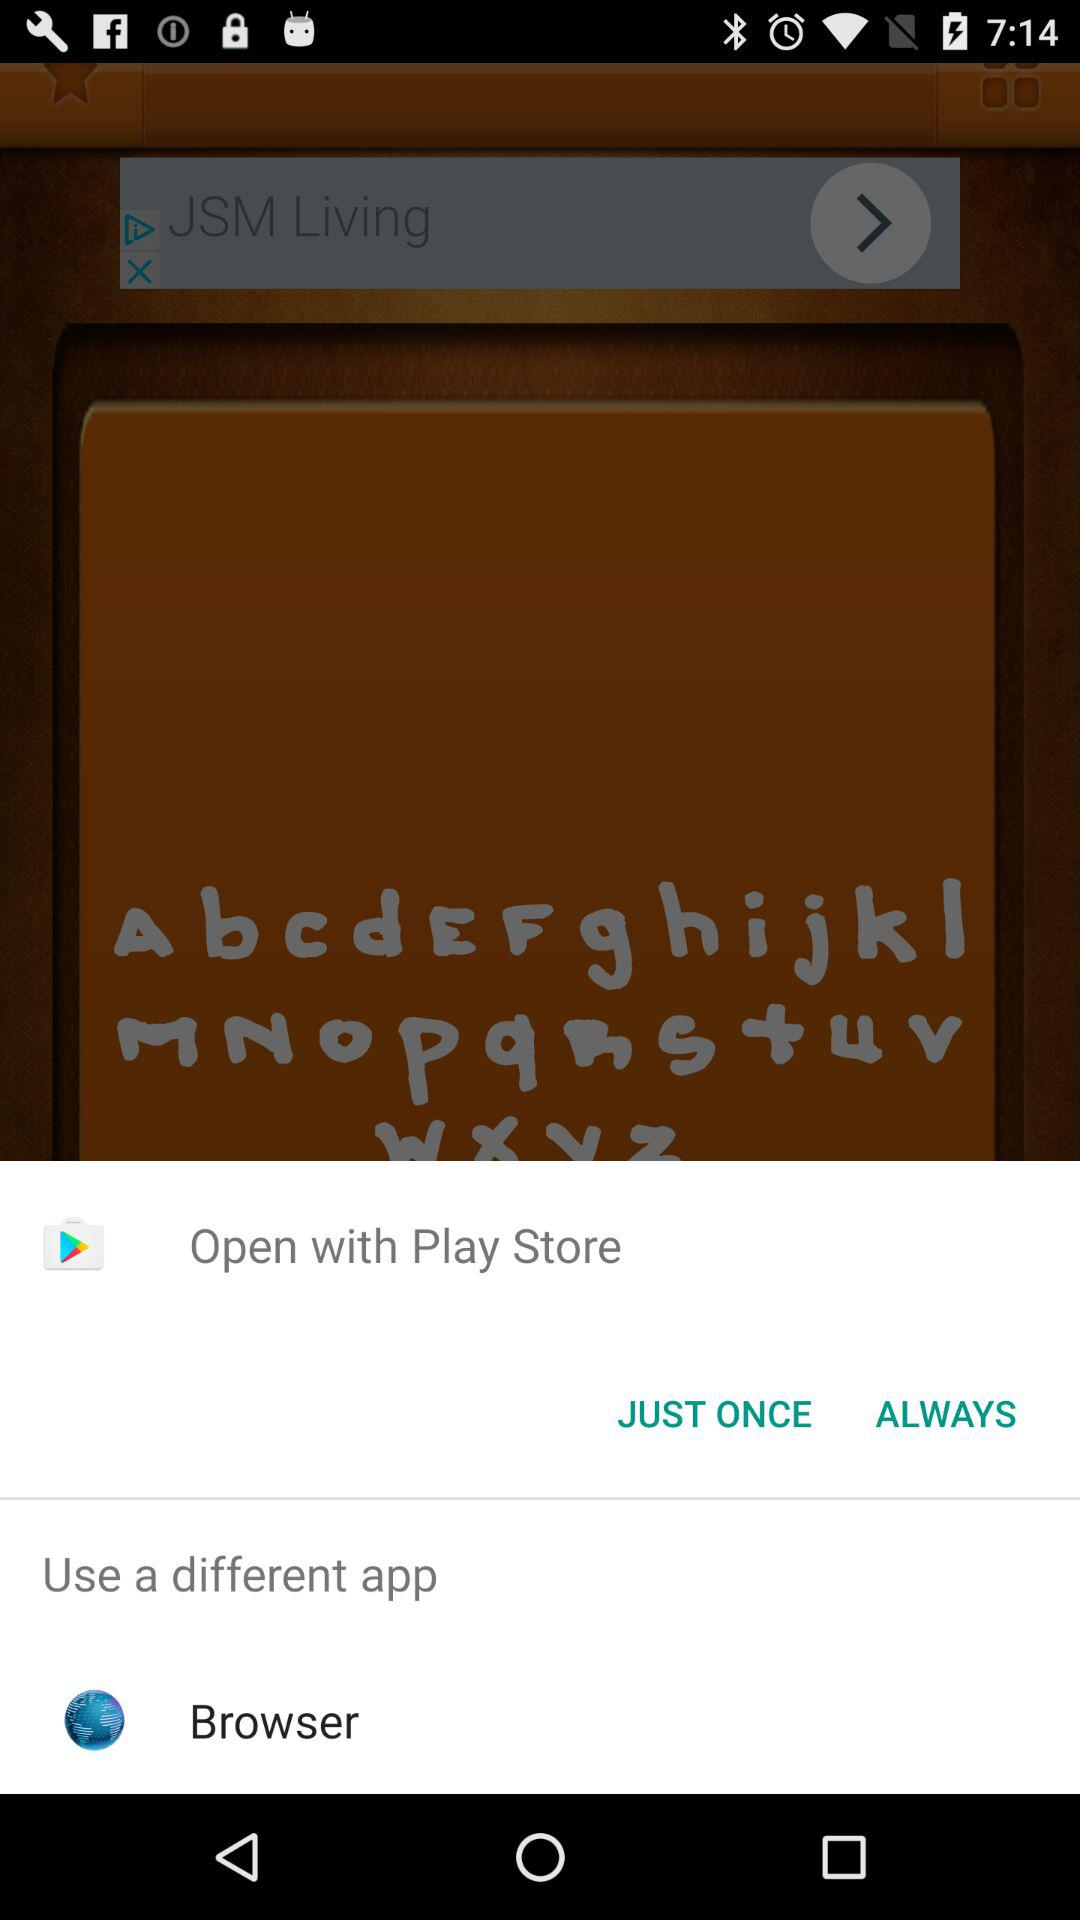What different applications can be used to open the content? The different application that can be used to open the content is "Browser". 